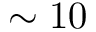Convert formula to latex. <formula><loc_0><loc_0><loc_500><loc_500>\sim 1 0</formula> 